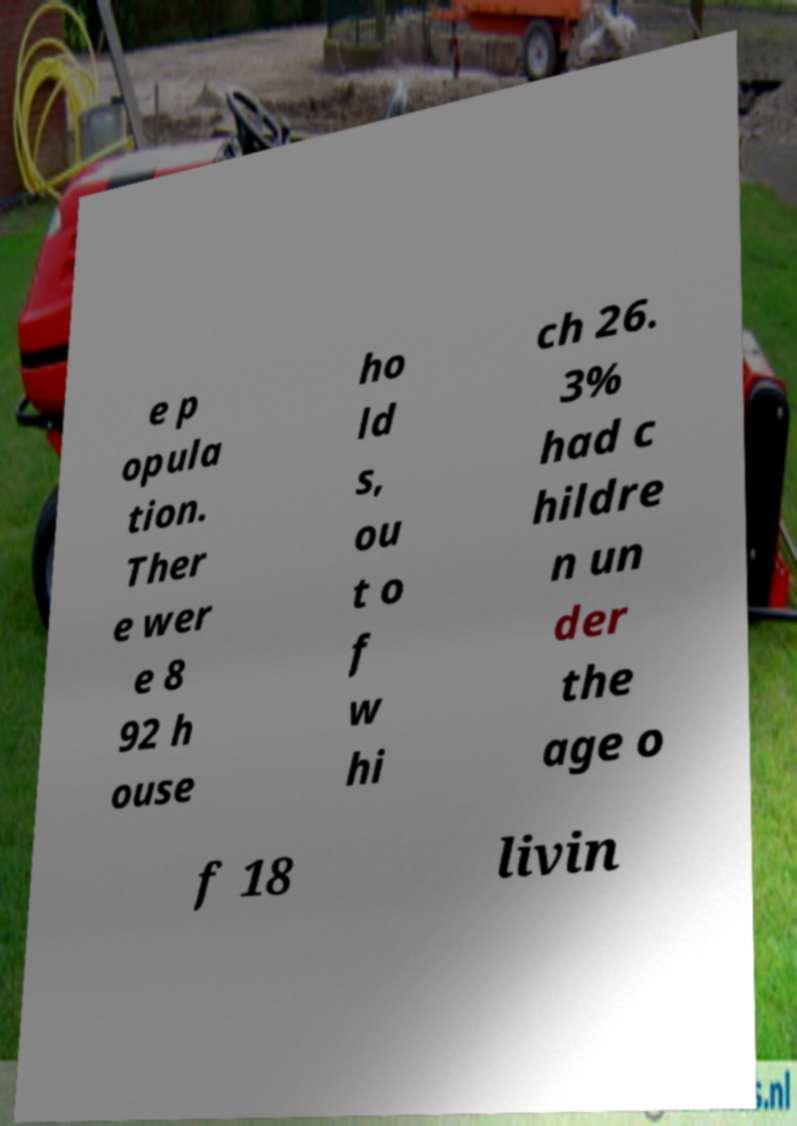What messages or text are displayed in this image? I need them in a readable, typed format. e p opula tion. Ther e wer e 8 92 h ouse ho ld s, ou t o f w hi ch 26. 3% had c hildre n un der the age o f 18 livin 